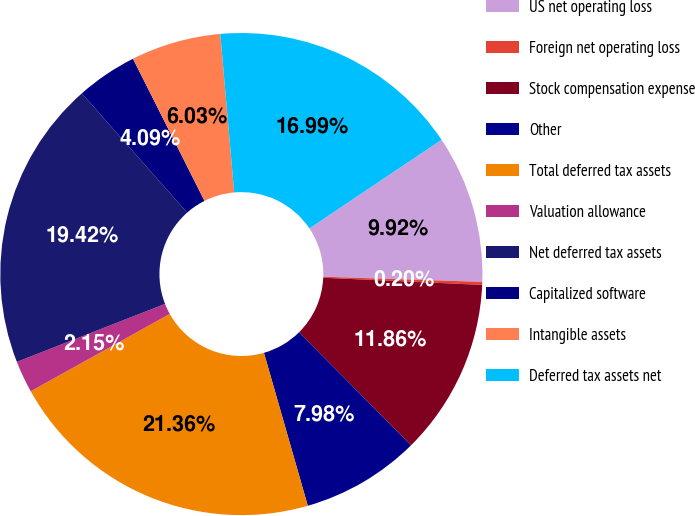Convert chart. <chart><loc_0><loc_0><loc_500><loc_500><pie_chart><fcel>US net operating loss<fcel>Foreign net operating loss<fcel>Stock compensation expense<fcel>Other<fcel>Total deferred tax assets<fcel>Valuation allowance<fcel>Net deferred tax assets<fcel>Capitalized software<fcel>Intangible assets<fcel>Deferred tax assets net<nl><fcel>9.92%<fcel>0.2%<fcel>11.86%<fcel>7.98%<fcel>21.36%<fcel>2.15%<fcel>19.42%<fcel>4.09%<fcel>6.03%<fcel>16.99%<nl></chart> 